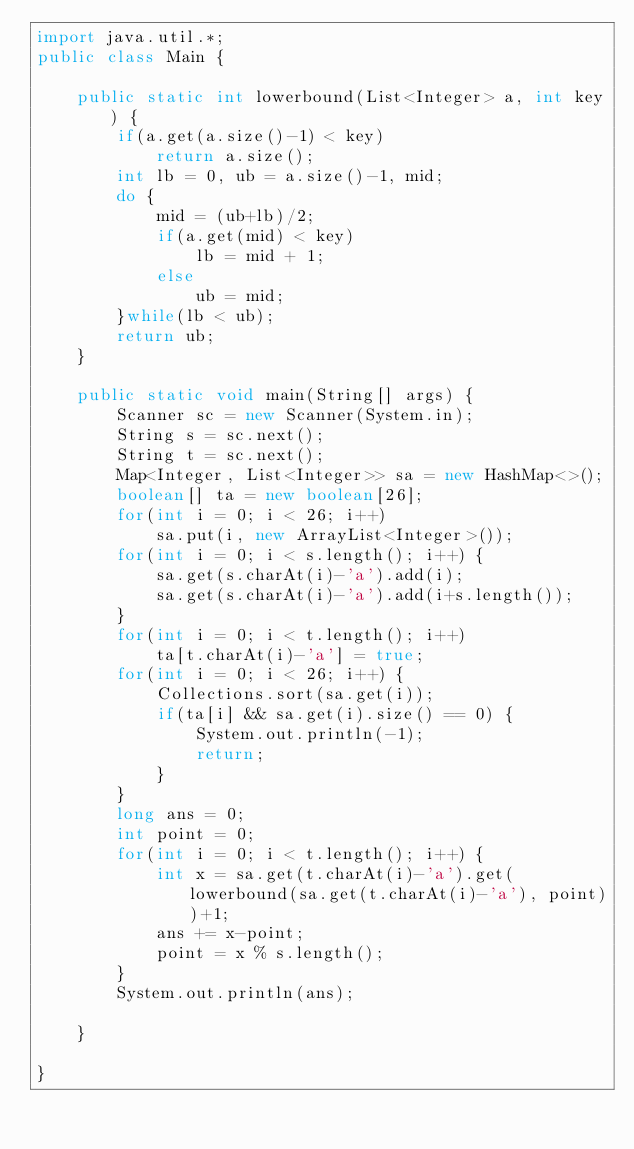<code> <loc_0><loc_0><loc_500><loc_500><_Java_>import java.util.*;
public class Main {

	public static int lowerbound(List<Integer> a, int key) {
		if(a.get(a.size()-1) < key)
			return a.size();
		int lb = 0, ub = a.size()-1, mid;
		do {
			mid = (ub+lb)/2;
			if(a.get(mid) < key)
				lb = mid + 1;
			else
				ub = mid;
		}while(lb < ub);
		return ub;
	}
	
	public static void main(String[] args) {
		Scanner sc = new Scanner(System.in);
		String s = sc.next();
		String t = sc.next();
		Map<Integer, List<Integer>> sa = new HashMap<>();
		boolean[] ta = new boolean[26];
		for(int i = 0; i < 26; i++)
			sa.put(i, new ArrayList<Integer>());
		for(int i = 0; i < s.length(); i++) {
			sa.get(s.charAt(i)-'a').add(i);
			sa.get(s.charAt(i)-'a').add(i+s.length());
		}
		for(int i = 0; i < t.length(); i++)
			ta[t.charAt(i)-'a'] = true;
		for(int i = 0; i < 26; i++) {
			Collections.sort(sa.get(i));
			if(ta[i] && sa.get(i).size() == 0) {
				System.out.println(-1);
				return;
			}
		}
		long ans = 0;
		int point = 0;
		for(int i = 0; i < t.length(); i++) {
			int x = sa.get(t.charAt(i)-'a').get(lowerbound(sa.get(t.charAt(i)-'a'), point))+1;
			ans += x-point;
			point = x % s.length();
		}
		System.out.println(ans);

	}

}</code> 